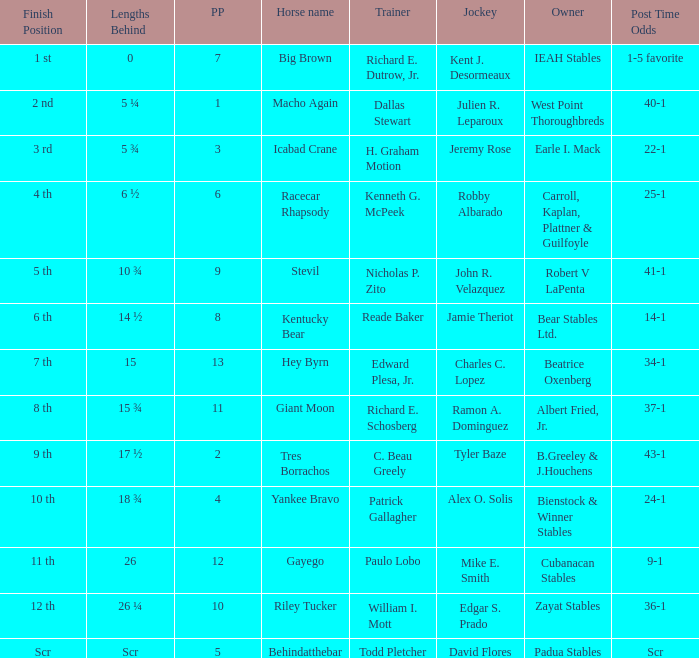Who is the owner of Icabad Crane? Earle I. Mack. 